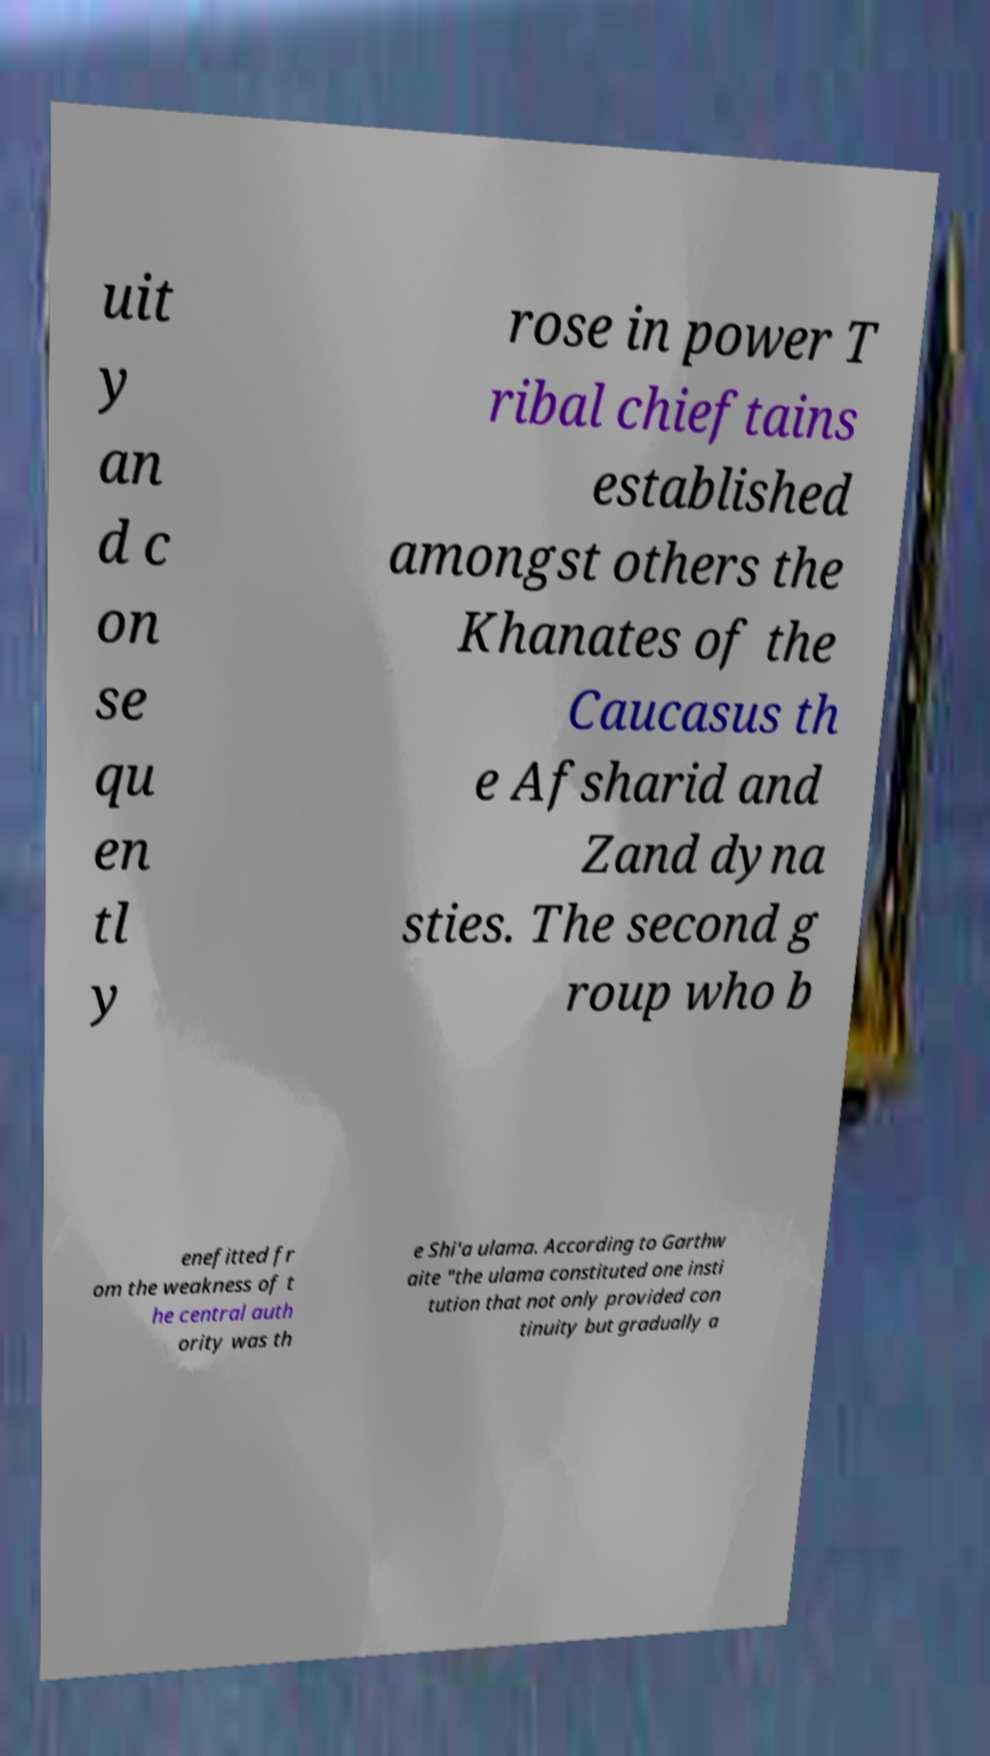I need the written content from this picture converted into text. Can you do that? uit y an d c on se qu en tl y rose in power T ribal chieftains established amongst others the Khanates of the Caucasus th e Afsharid and Zand dyna sties. The second g roup who b enefitted fr om the weakness of t he central auth ority was th e Shi'a ulama. According to Garthw aite "the ulama constituted one insti tution that not only provided con tinuity but gradually a 